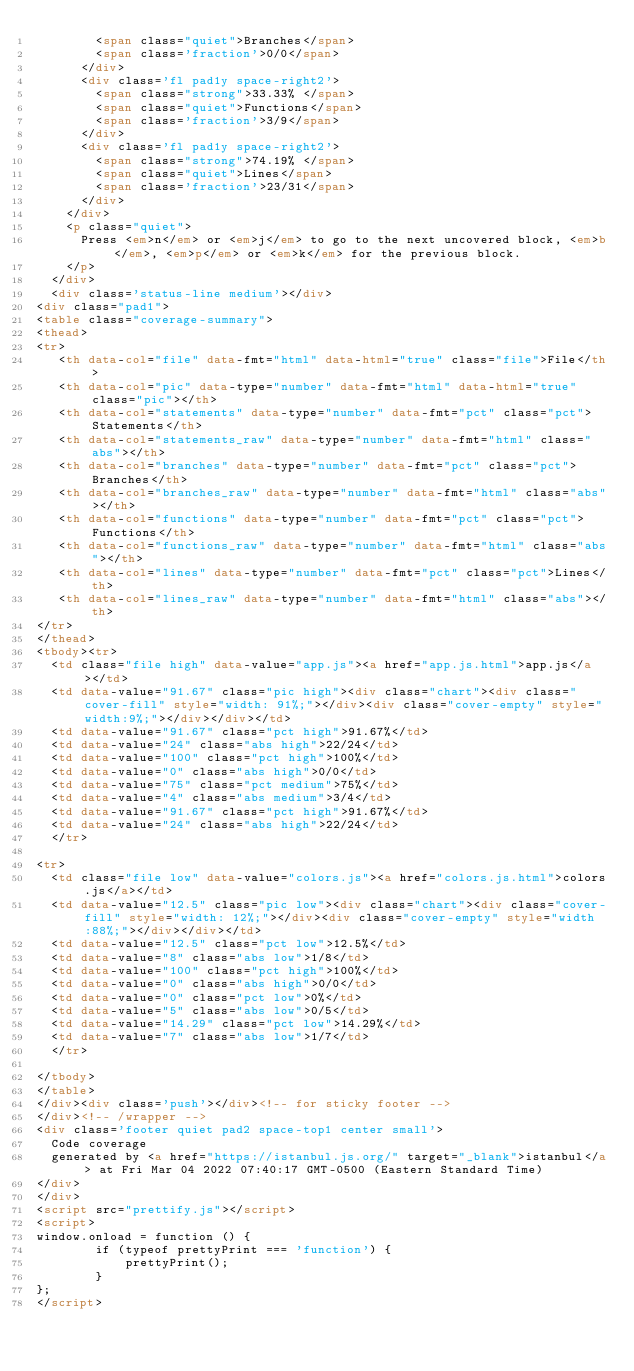<code> <loc_0><loc_0><loc_500><loc_500><_HTML_>        <span class="quiet">Branches</span>
        <span class='fraction'>0/0</span>
      </div>
      <div class='fl pad1y space-right2'>
        <span class="strong">33.33% </span>
        <span class="quiet">Functions</span>
        <span class='fraction'>3/9</span>
      </div>
      <div class='fl pad1y space-right2'>
        <span class="strong">74.19% </span>
        <span class="quiet">Lines</span>
        <span class='fraction'>23/31</span>
      </div>
    </div>
    <p class="quiet">
      Press <em>n</em> or <em>j</em> to go to the next uncovered block, <em>b</em>, <em>p</em> or <em>k</em> for the previous block.
    </p>
  </div>
  <div class='status-line medium'></div>
<div class="pad1">
<table class="coverage-summary">
<thead>
<tr>
   <th data-col="file" data-fmt="html" data-html="true" class="file">File</th>
   <th data-col="pic" data-type="number" data-fmt="html" data-html="true" class="pic"></th>
   <th data-col="statements" data-type="number" data-fmt="pct" class="pct">Statements</th>
   <th data-col="statements_raw" data-type="number" data-fmt="html" class="abs"></th>
   <th data-col="branches" data-type="number" data-fmt="pct" class="pct">Branches</th>
   <th data-col="branches_raw" data-type="number" data-fmt="html" class="abs"></th>
   <th data-col="functions" data-type="number" data-fmt="pct" class="pct">Functions</th>
   <th data-col="functions_raw" data-type="number" data-fmt="html" class="abs"></th>
   <th data-col="lines" data-type="number" data-fmt="pct" class="pct">Lines</th>
   <th data-col="lines_raw" data-type="number" data-fmt="html" class="abs"></th>
</tr>
</thead>
<tbody><tr>
	<td class="file high" data-value="app.js"><a href="app.js.html">app.js</a></td>
	<td data-value="91.67" class="pic high"><div class="chart"><div class="cover-fill" style="width: 91%;"></div><div class="cover-empty" style="width:9%;"></div></div></td>
	<td data-value="91.67" class="pct high">91.67%</td>
	<td data-value="24" class="abs high">22/24</td>
	<td data-value="100" class="pct high">100%</td>
	<td data-value="0" class="abs high">0/0</td>
	<td data-value="75" class="pct medium">75%</td>
	<td data-value="4" class="abs medium">3/4</td>
	<td data-value="91.67" class="pct high">91.67%</td>
	<td data-value="24" class="abs high">22/24</td>
	</tr>

<tr>
	<td class="file low" data-value="colors.js"><a href="colors.js.html">colors.js</a></td>
	<td data-value="12.5" class="pic low"><div class="chart"><div class="cover-fill" style="width: 12%;"></div><div class="cover-empty" style="width:88%;"></div></div></td>
	<td data-value="12.5" class="pct low">12.5%</td>
	<td data-value="8" class="abs low">1/8</td>
	<td data-value="100" class="pct high">100%</td>
	<td data-value="0" class="abs high">0/0</td>
	<td data-value="0" class="pct low">0%</td>
	<td data-value="5" class="abs low">0/5</td>
	<td data-value="14.29" class="pct low">14.29%</td>
	<td data-value="7" class="abs low">1/7</td>
	</tr>

</tbody>
</table>
</div><div class='push'></div><!-- for sticky footer -->
</div><!-- /wrapper -->
<div class='footer quiet pad2 space-top1 center small'>
  Code coverage
  generated by <a href="https://istanbul.js.org/" target="_blank">istanbul</a> at Fri Mar 04 2022 07:40:17 GMT-0500 (Eastern Standard Time)
</div>
</div>
<script src="prettify.js"></script>
<script>
window.onload = function () {
        if (typeof prettyPrint === 'function') {
            prettyPrint();
        }
};
</script></code> 